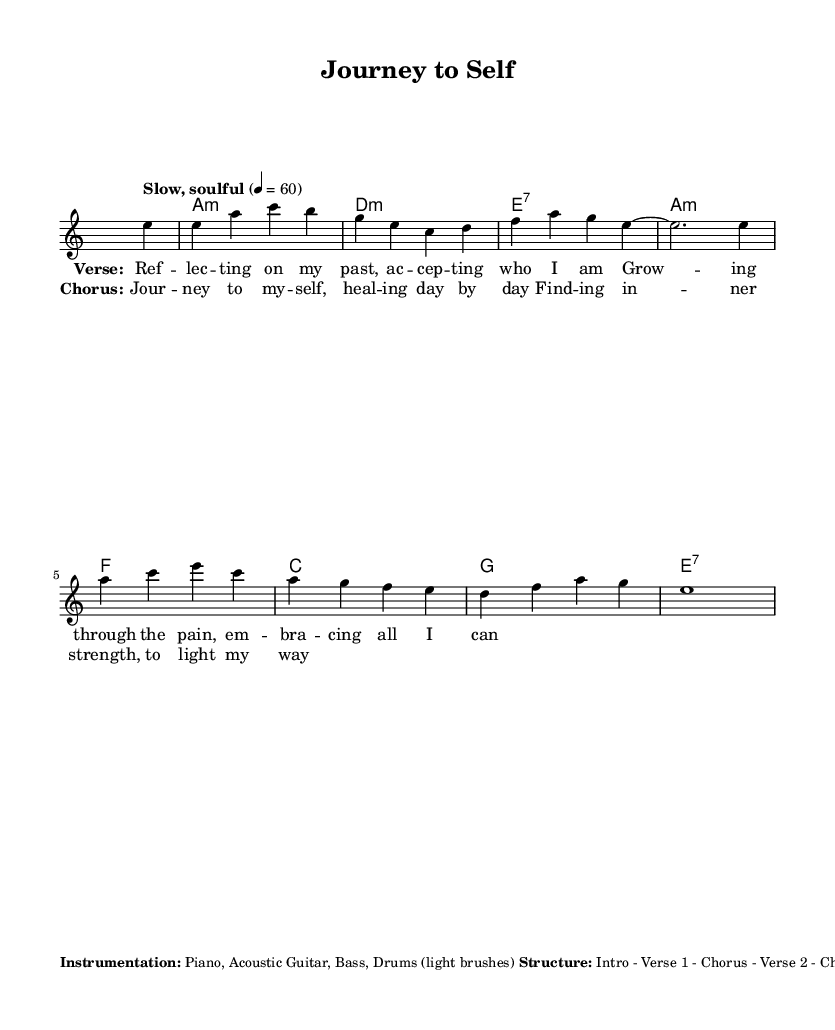What is the key signature of this music? The key signature is A minor, which has no sharps or flats.
Answer: A minor What is the time signature of the music? The time signature is indicated by the notation, which shows a 4 over 4.
Answer: 4/4 What is the tempo marking for the piece? The tempo marking is indicated by the word "Slow, soulful" with a metronome marking of 60 beats per minute.
Answer: Slow, soulful, 4 = 60 How many verses are in the song structure? By analyzing the structure provided, there are two verses mentioned in the layout of the music.
Answer: Two What type of accompaniment is suggested for the guitar? The sheet mentions that the guitar part should consist of fingerpicked arpeggios.
Answer: Fingerpicked arpeggios Why does the dynamics change in the bridge section? The score suggests that the bridge is meant to be slightly more intense, which contrasts with the gradual buildup of earlier sections, emphasizing emotional growth and change. This reflects the blues genre's focus on expressing deep emotions.
Answer: To create intensity What instrumentation is specified for the performance? The instrumentation is clearly listed in the markup at the end of the sheet music, including piano, acoustic guitar, bass, and drums.
Answer: Piano, Acoustic Guitar, Bass, Drums 